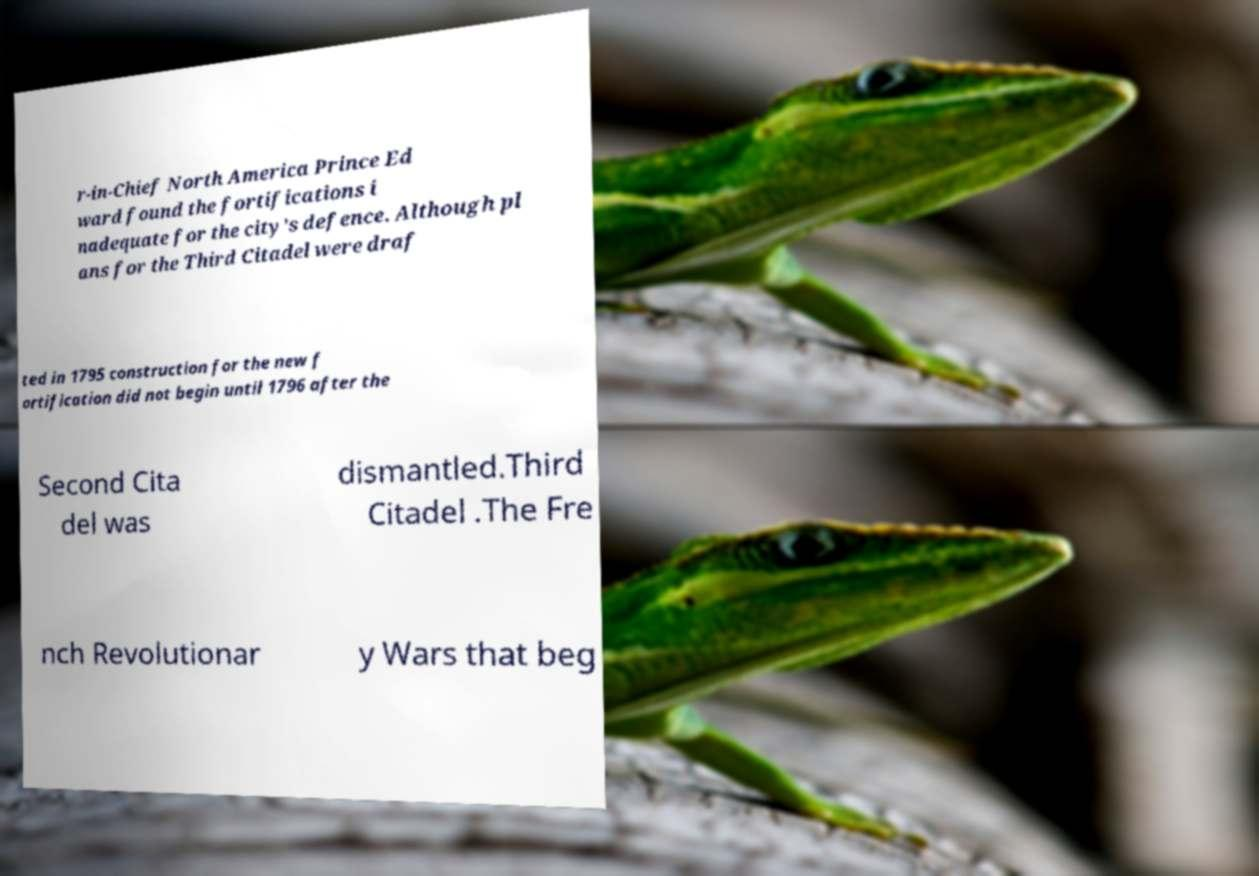What messages or text are displayed in this image? I need them in a readable, typed format. r-in-Chief North America Prince Ed ward found the fortifications i nadequate for the city's defence. Although pl ans for the Third Citadel were draf ted in 1795 construction for the new f ortification did not begin until 1796 after the Second Cita del was dismantled.Third Citadel .The Fre nch Revolutionar y Wars that beg 